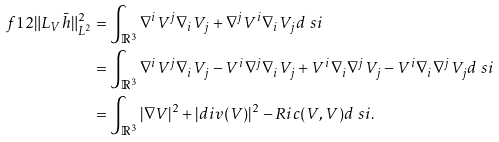<formula> <loc_0><loc_0><loc_500><loc_500>\ f 1 2 \| L _ { V } \bar { h } \| _ { L ^ { 2 } } ^ { 2 } & = \int _ { \mathbb { R } ^ { 3 } } \nabla ^ { i } V ^ { j } \nabla _ { i } V _ { j } + \nabla ^ { j } V ^ { i } \nabla _ { i } V _ { j } d \ s i \\ & = \int _ { \mathbb { R } ^ { 3 } } \nabla ^ { i } V ^ { j } \nabla _ { i } V _ { j } - V ^ { i } \nabla ^ { j } \nabla _ { i } V _ { j } + V ^ { i } \nabla _ { i } \nabla ^ { j } V _ { j } - V ^ { i } \nabla _ { i } \nabla ^ { j } V _ { j } d \ s i \\ & = \int _ { \mathbb { R } ^ { 3 } } | \nabla V | ^ { 2 } + | d i v ( V ) | ^ { 2 } - R i c ( V , V ) d \ s i .</formula> 